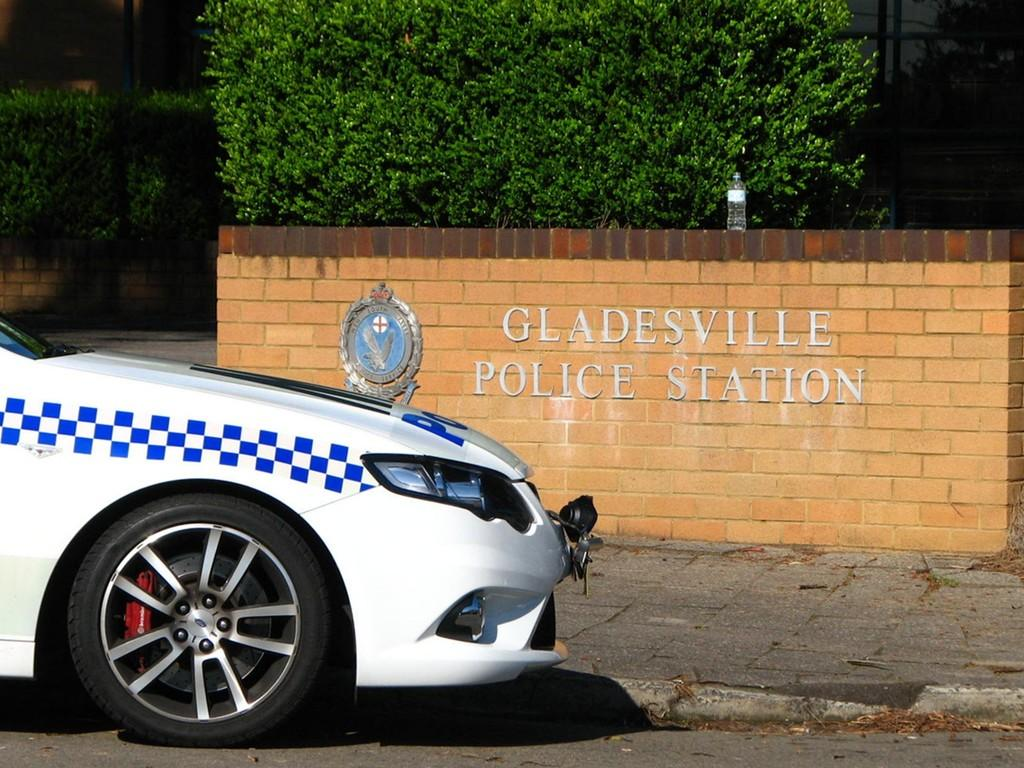What is the main subject of the image? There is a car on the road at the bottom of the image. What can be seen in the background of the image? There is a wall in the background of the image. What is placed on the wall? A bottle is placed on the wall. What type of vegetation is visible in the image? There are bushes visible in the image. How does the love between the two people in the image manifest itself? There are no people present in the image, let alone any indication of love between them. 